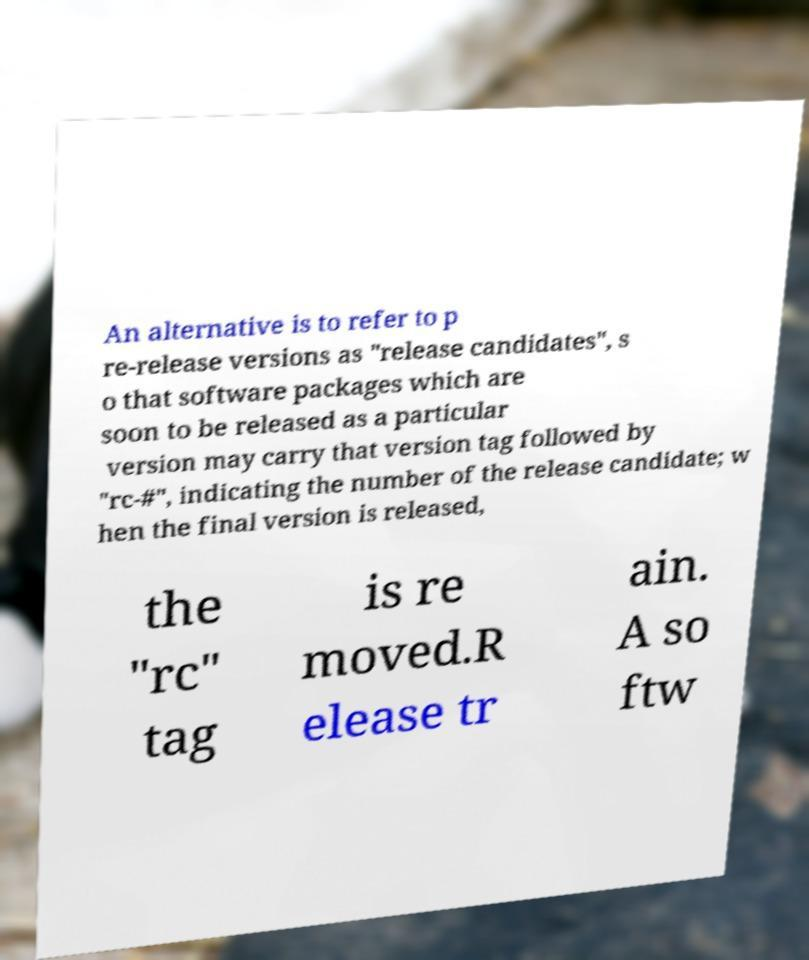I need the written content from this picture converted into text. Can you do that? An alternative is to refer to p re-release versions as "release candidates", s o that software packages which are soon to be released as a particular version may carry that version tag followed by "rc-#", indicating the number of the release candidate; w hen the final version is released, the "rc" tag is re moved.R elease tr ain. A so ftw 